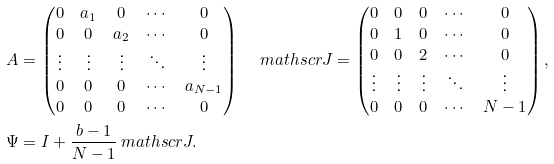<formula> <loc_0><loc_0><loc_500><loc_500>A & = \begin{pmatrix} 0 & a _ { 1 } & 0 & \cdots & 0 \\ 0 & 0 & a _ { 2 } & \cdots & 0 \\ \vdots & \vdots & \vdots & \ddots & \vdots \\ 0 & 0 & 0 & \cdots & a _ { N - 1 } \\ 0 & 0 & 0 & \cdots & 0 \end{pmatrix} \quad \ m a t h s c r { J } = \begin{pmatrix} 0 & 0 & 0 & \cdots & 0 \\ 0 & 1 & 0 & \cdots & 0 \\ 0 & 0 & 2 & \cdots & 0 \\ \vdots & \vdots & \vdots & \ddots & \vdots \\ 0 & 0 & 0 & \cdots & N - 1 \end{pmatrix} , \\ \Psi & = I + \frac { b - 1 } { N - 1 } \ m a t h s c r { J } .</formula> 